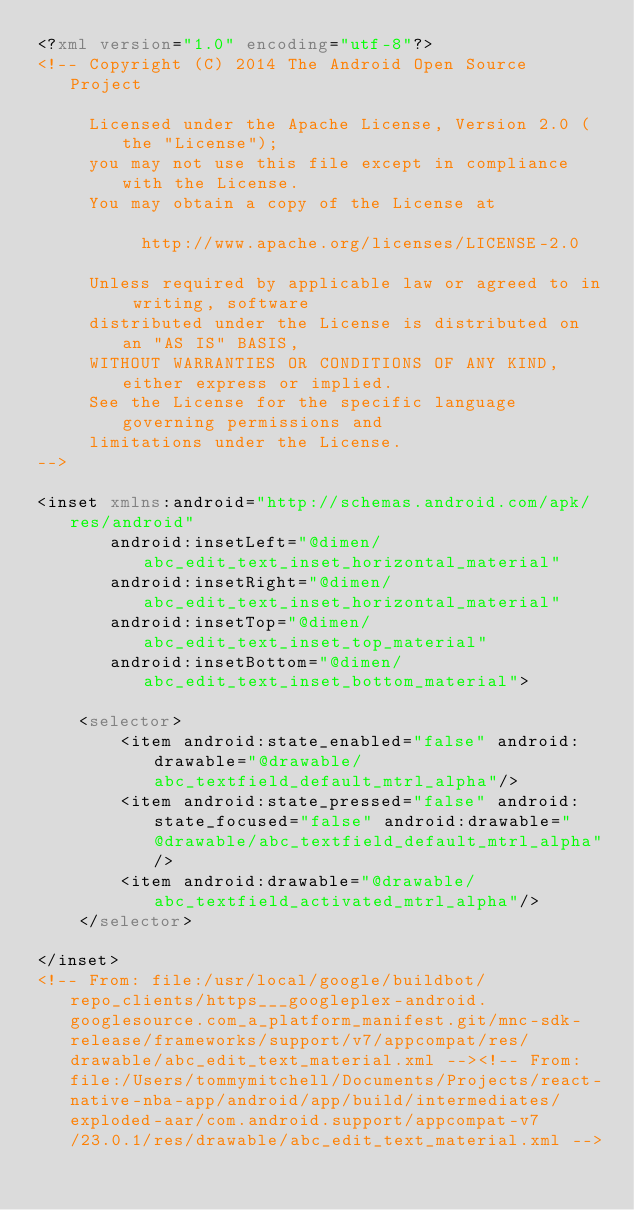<code> <loc_0><loc_0><loc_500><loc_500><_XML_><?xml version="1.0" encoding="utf-8"?>
<!-- Copyright (C) 2014 The Android Open Source Project

     Licensed under the Apache License, Version 2.0 (the "License");
     you may not use this file except in compliance with the License.
     You may obtain a copy of the License at

          http://www.apache.org/licenses/LICENSE-2.0

     Unless required by applicable law or agreed to in writing, software
     distributed under the License is distributed on an "AS IS" BASIS,
     WITHOUT WARRANTIES OR CONDITIONS OF ANY KIND, either express or implied.
     See the License for the specific language governing permissions and
     limitations under the License.
-->

<inset xmlns:android="http://schemas.android.com/apk/res/android"
       android:insetLeft="@dimen/abc_edit_text_inset_horizontal_material"
       android:insetRight="@dimen/abc_edit_text_inset_horizontal_material"
       android:insetTop="@dimen/abc_edit_text_inset_top_material"
       android:insetBottom="@dimen/abc_edit_text_inset_bottom_material">

    <selector>
        <item android:state_enabled="false" android:drawable="@drawable/abc_textfield_default_mtrl_alpha"/>
        <item android:state_pressed="false" android:state_focused="false" android:drawable="@drawable/abc_textfield_default_mtrl_alpha"/>
        <item android:drawable="@drawable/abc_textfield_activated_mtrl_alpha"/>
    </selector>

</inset>
<!-- From: file:/usr/local/google/buildbot/repo_clients/https___googleplex-android.googlesource.com_a_platform_manifest.git/mnc-sdk-release/frameworks/support/v7/appcompat/res/drawable/abc_edit_text_material.xml --><!-- From: file:/Users/tommymitchell/Documents/Projects/react-native-nba-app/android/app/build/intermediates/exploded-aar/com.android.support/appcompat-v7/23.0.1/res/drawable/abc_edit_text_material.xml --></code> 